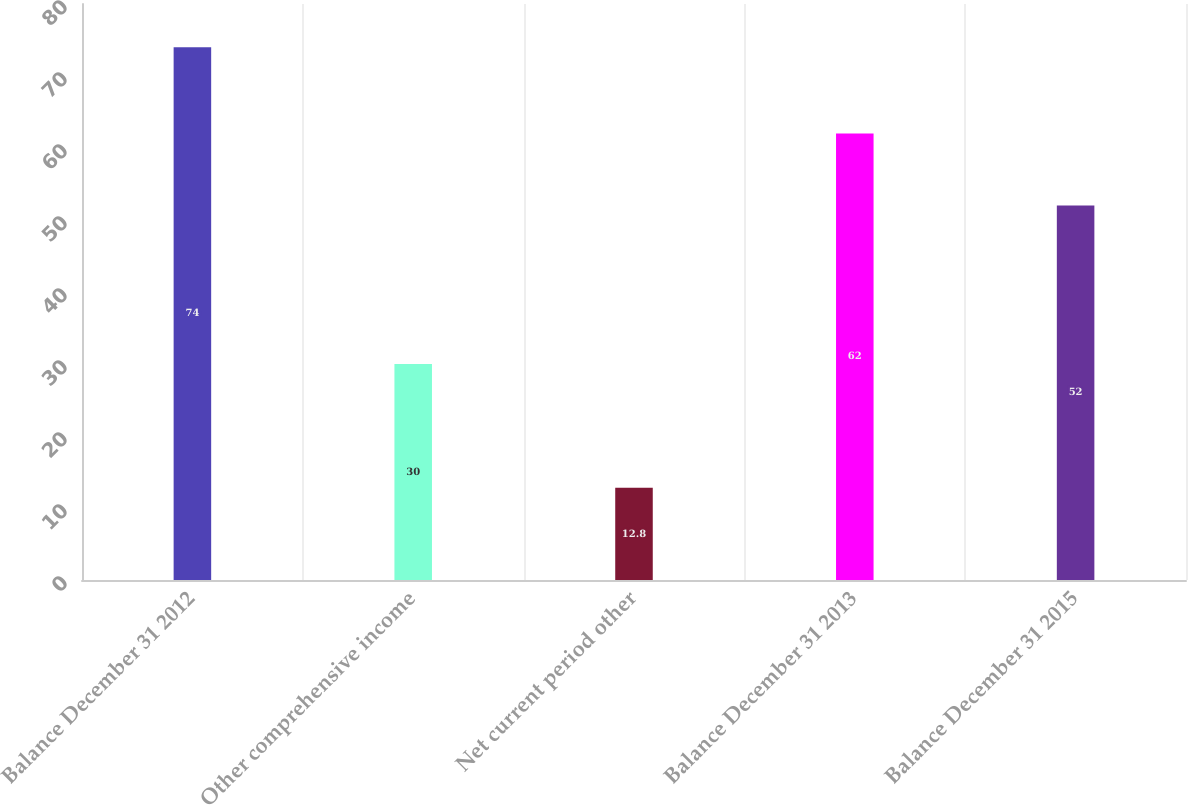Convert chart. <chart><loc_0><loc_0><loc_500><loc_500><bar_chart><fcel>Balance December 31 2012<fcel>Other comprehensive income<fcel>Net current period other<fcel>Balance December 31 2013<fcel>Balance December 31 2015<nl><fcel>74<fcel>30<fcel>12.8<fcel>62<fcel>52<nl></chart> 